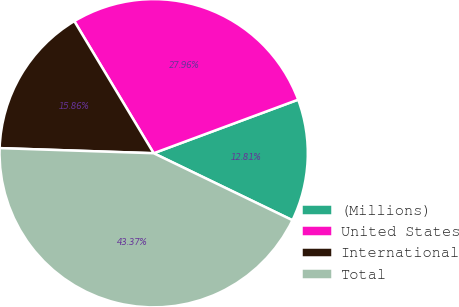Convert chart. <chart><loc_0><loc_0><loc_500><loc_500><pie_chart><fcel>(Millions)<fcel>United States<fcel>International<fcel>Total<nl><fcel>12.81%<fcel>27.96%<fcel>15.86%<fcel>43.37%<nl></chart> 